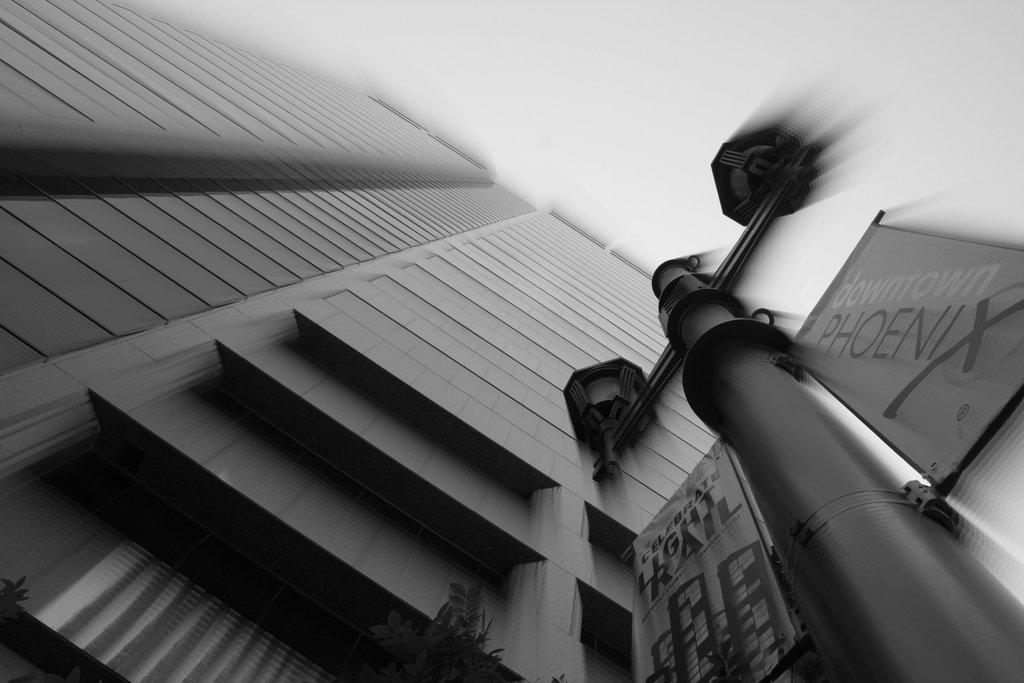What is the color scheme of the image? The image is a black and white picture. What type of structure is visible in the image? There is a building in the image. What is located on the right side of the image? There is a pole on the right side of the image. What is attached to the pole? Banners are attached to the pole. What can be read on the banners? Text is written on the banners. Where is the cup placed on the shelf in the image? There is no cup or shelf present in the image. What type of mailbox is visible in the image? There is no mailbox visible in the image. 